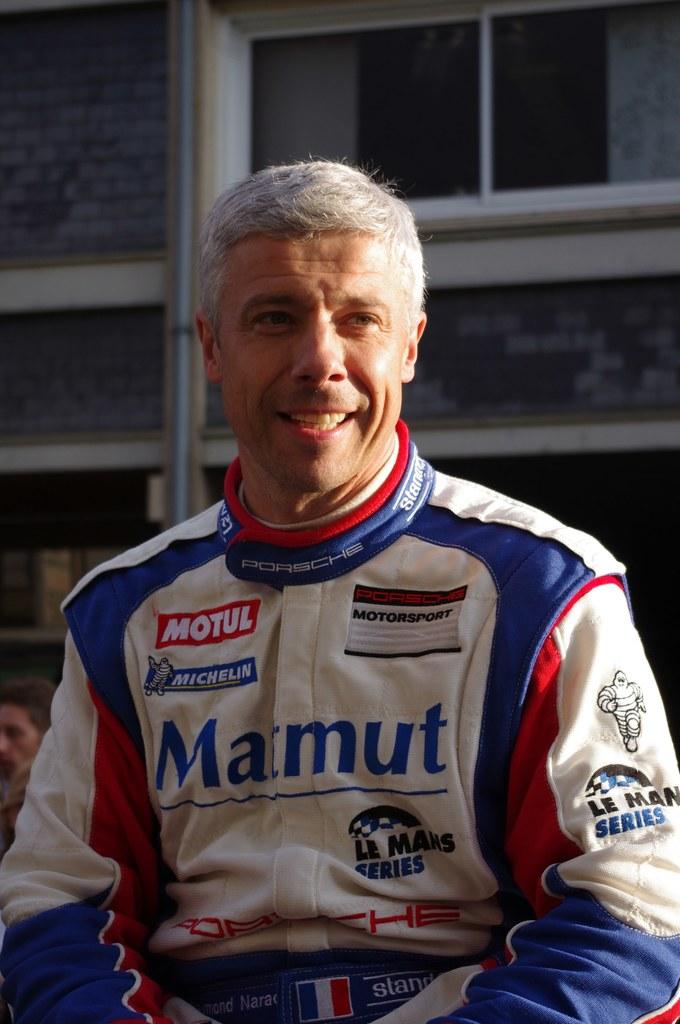What is the name of the sponsor on the top left of this racing jacket?
Give a very brief answer. Motul. What is the name on the jacket?
Your response must be concise. Marmut. 